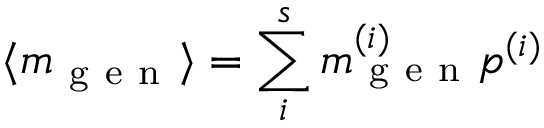<formula> <loc_0><loc_0><loc_500><loc_500>\langle m _ { g e n } \rangle = \sum _ { i } ^ { s } m _ { g e n } ^ { ( i ) } p ^ { ( i ) }</formula> 